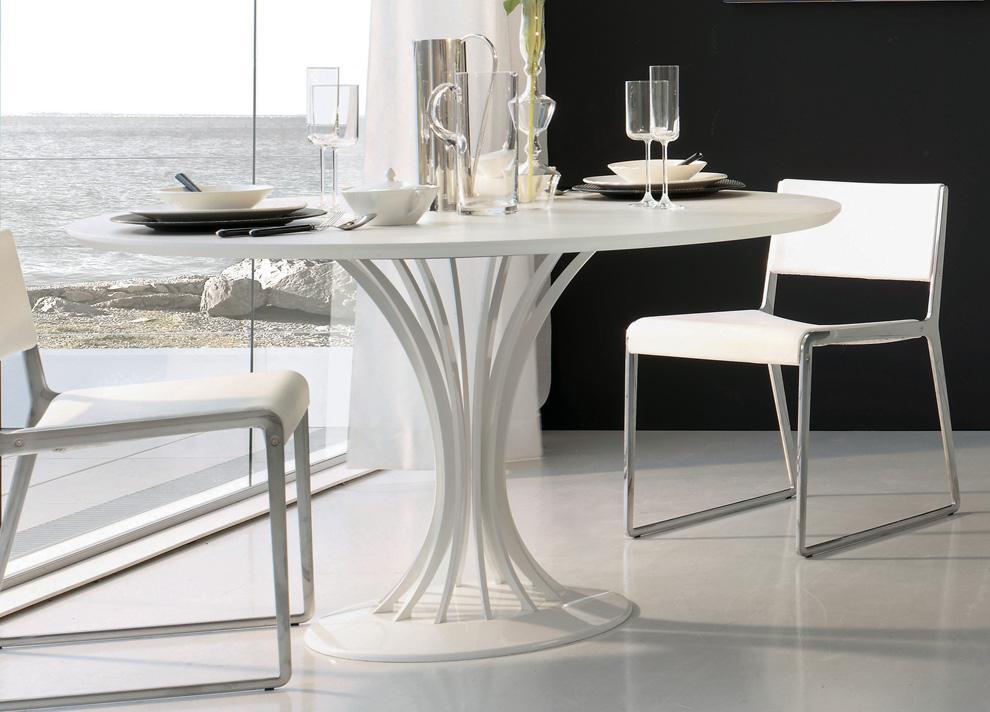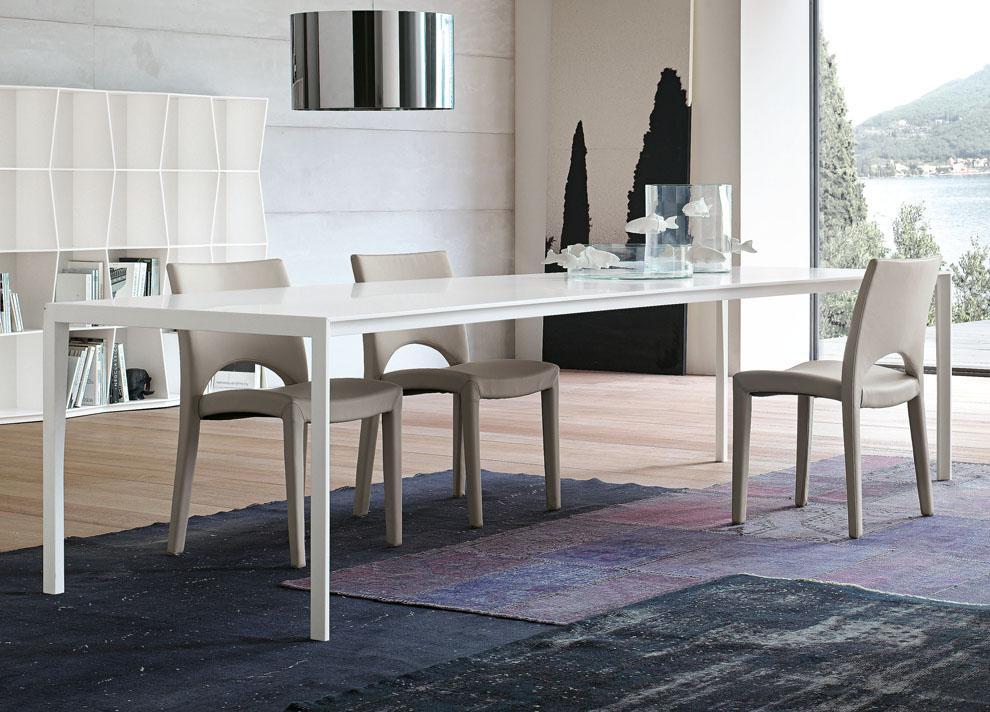The first image is the image on the left, the second image is the image on the right. Evaluate the accuracy of this statement regarding the images: "One of the tables is round.". Is it true? Answer yes or no. Yes. The first image is the image on the left, the second image is the image on the right. Analyze the images presented: Is the assertion "A table in one image is round with two chairs." valid? Answer yes or no. Yes. 